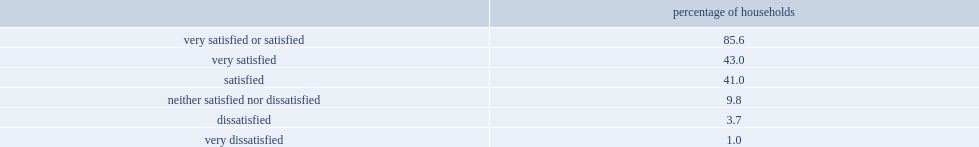How many percent of households are very satisfied with the neighbourhood? 43.0. How many percent of households are satisfied with the neighbourhood? 41.0. How many percent of households are dissatisfied with the neighbourhood. 9.8. How many percent of households are very dissatisfied with the neighbourhood? 3.7. How many percent of households are neither satisfied nor dissatisfied with the neighbourhood? 1.0. 